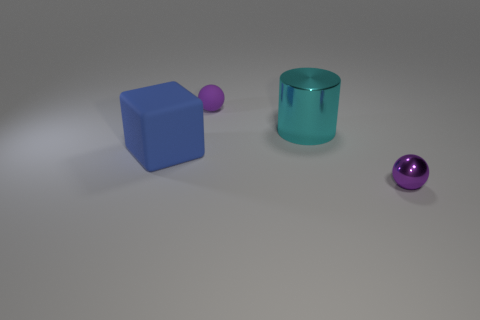There is a small object that is left of the cyan thing; how many purple things are left of it?
Your answer should be very brief. 0. Is there a rubber object that is right of the big object that is to the right of the matte thing that is to the right of the large blue thing?
Offer a very short reply. No. What material is the other small purple object that is the same shape as the purple matte object?
Ensure brevity in your answer.  Metal. Is there any other thing that has the same material as the cyan object?
Offer a very short reply. Yes. Does the cylinder have the same material as the sphere that is in front of the tiny purple matte object?
Ensure brevity in your answer.  Yes. There is a purple object right of the ball that is behind the cyan shiny object; what shape is it?
Provide a succinct answer. Sphere. What number of big things are either cyan metal blocks or objects?
Offer a very short reply. 2. What number of other small shiny things have the same shape as the cyan object?
Make the answer very short. 0. Do the tiny purple metallic thing and the large thing that is behind the big matte thing have the same shape?
Provide a short and direct response. No. What number of metal cylinders are left of the large cyan cylinder?
Your response must be concise. 0. 